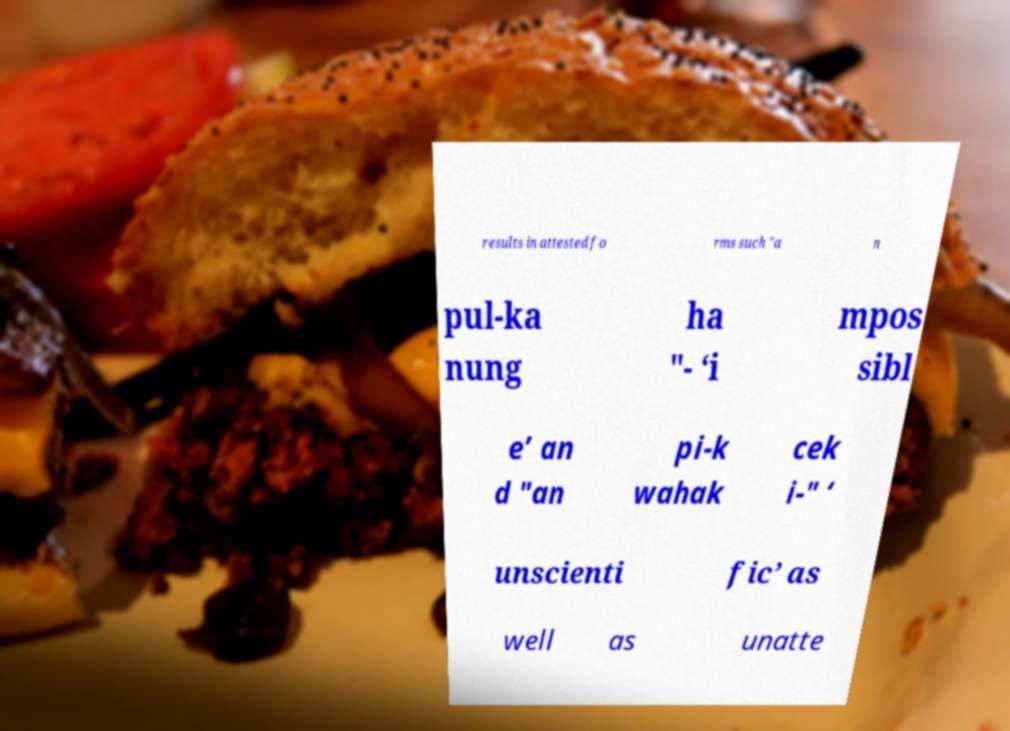Please read and relay the text visible in this image. What does it say? results in attested fo rms such "a n pul-ka nung ha "- ‘i mpos sibl e’ an d "an pi-k wahak cek i-" ‘ unscienti fic’ as well as unatte 